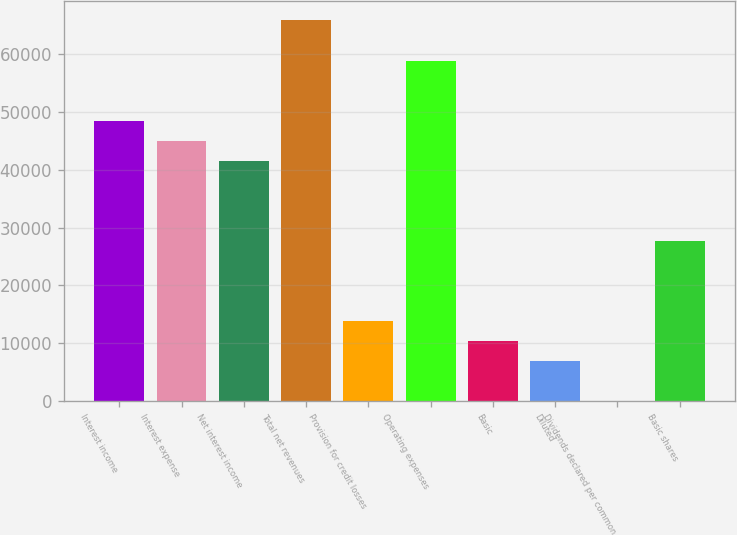<chart> <loc_0><loc_0><loc_500><loc_500><bar_chart><fcel>Interest income<fcel>Interest expense<fcel>Net interest income<fcel>Total net revenues<fcel>Provision for credit losses<fcel>Operating expenses<fcel>Basic<fcel>Diluted<fcel>Dividends declared per common<fcel>Basic shares<nl><fcel>48507.7<fcel>45043.1<fcel>41578.4<fcel>65831.1<fcel>13861<fcel>58901.8<fcel>10396.3<fcel>6931.6<fcel>2.25<fcel>27719.7<nl></chart> 